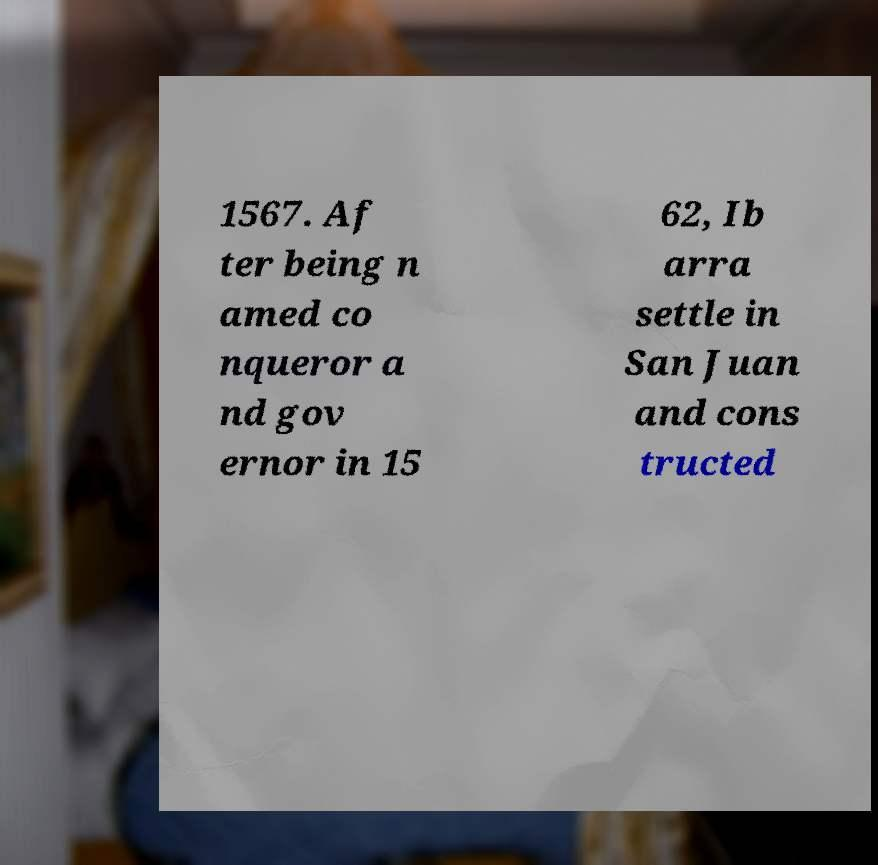Could you assist in decoding the text presented in this image and type it out clearly? 1567. Af ter being n amed co nqueror a nd gov ernor in 15 62, Ib arra settle in San Juan and cons tructed 